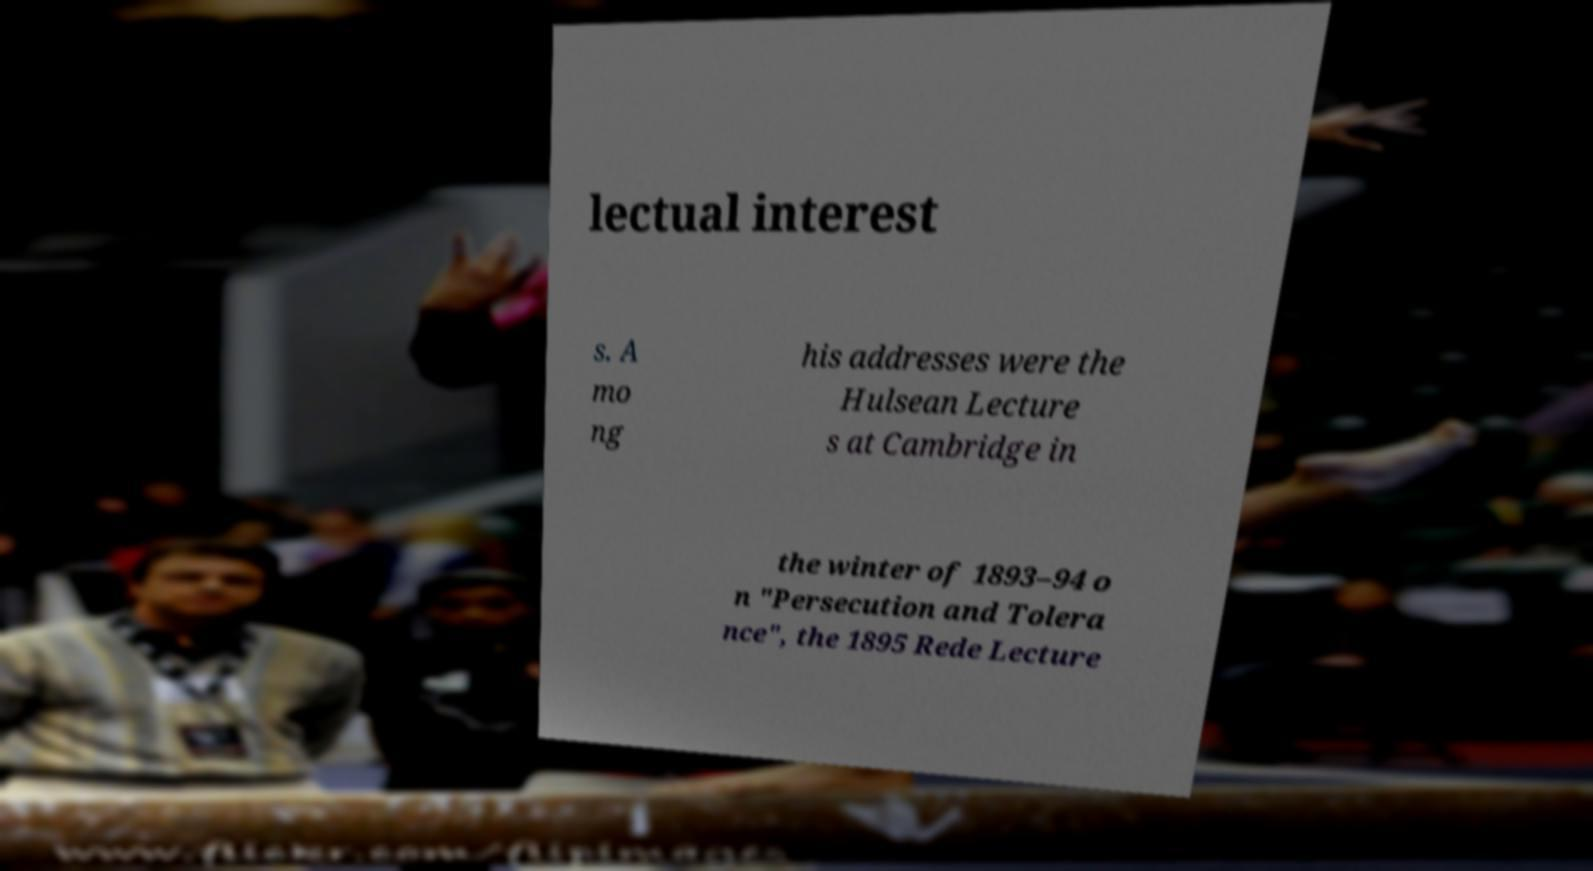Please identify and transcribe the text found in this image. lectual interest s. A mo ng his addresses were the Hulsean Lecture s at Cambridge in the winter of 1893–94 o n "Persecution and Tolera nce", the 1895 Rede Lecture 